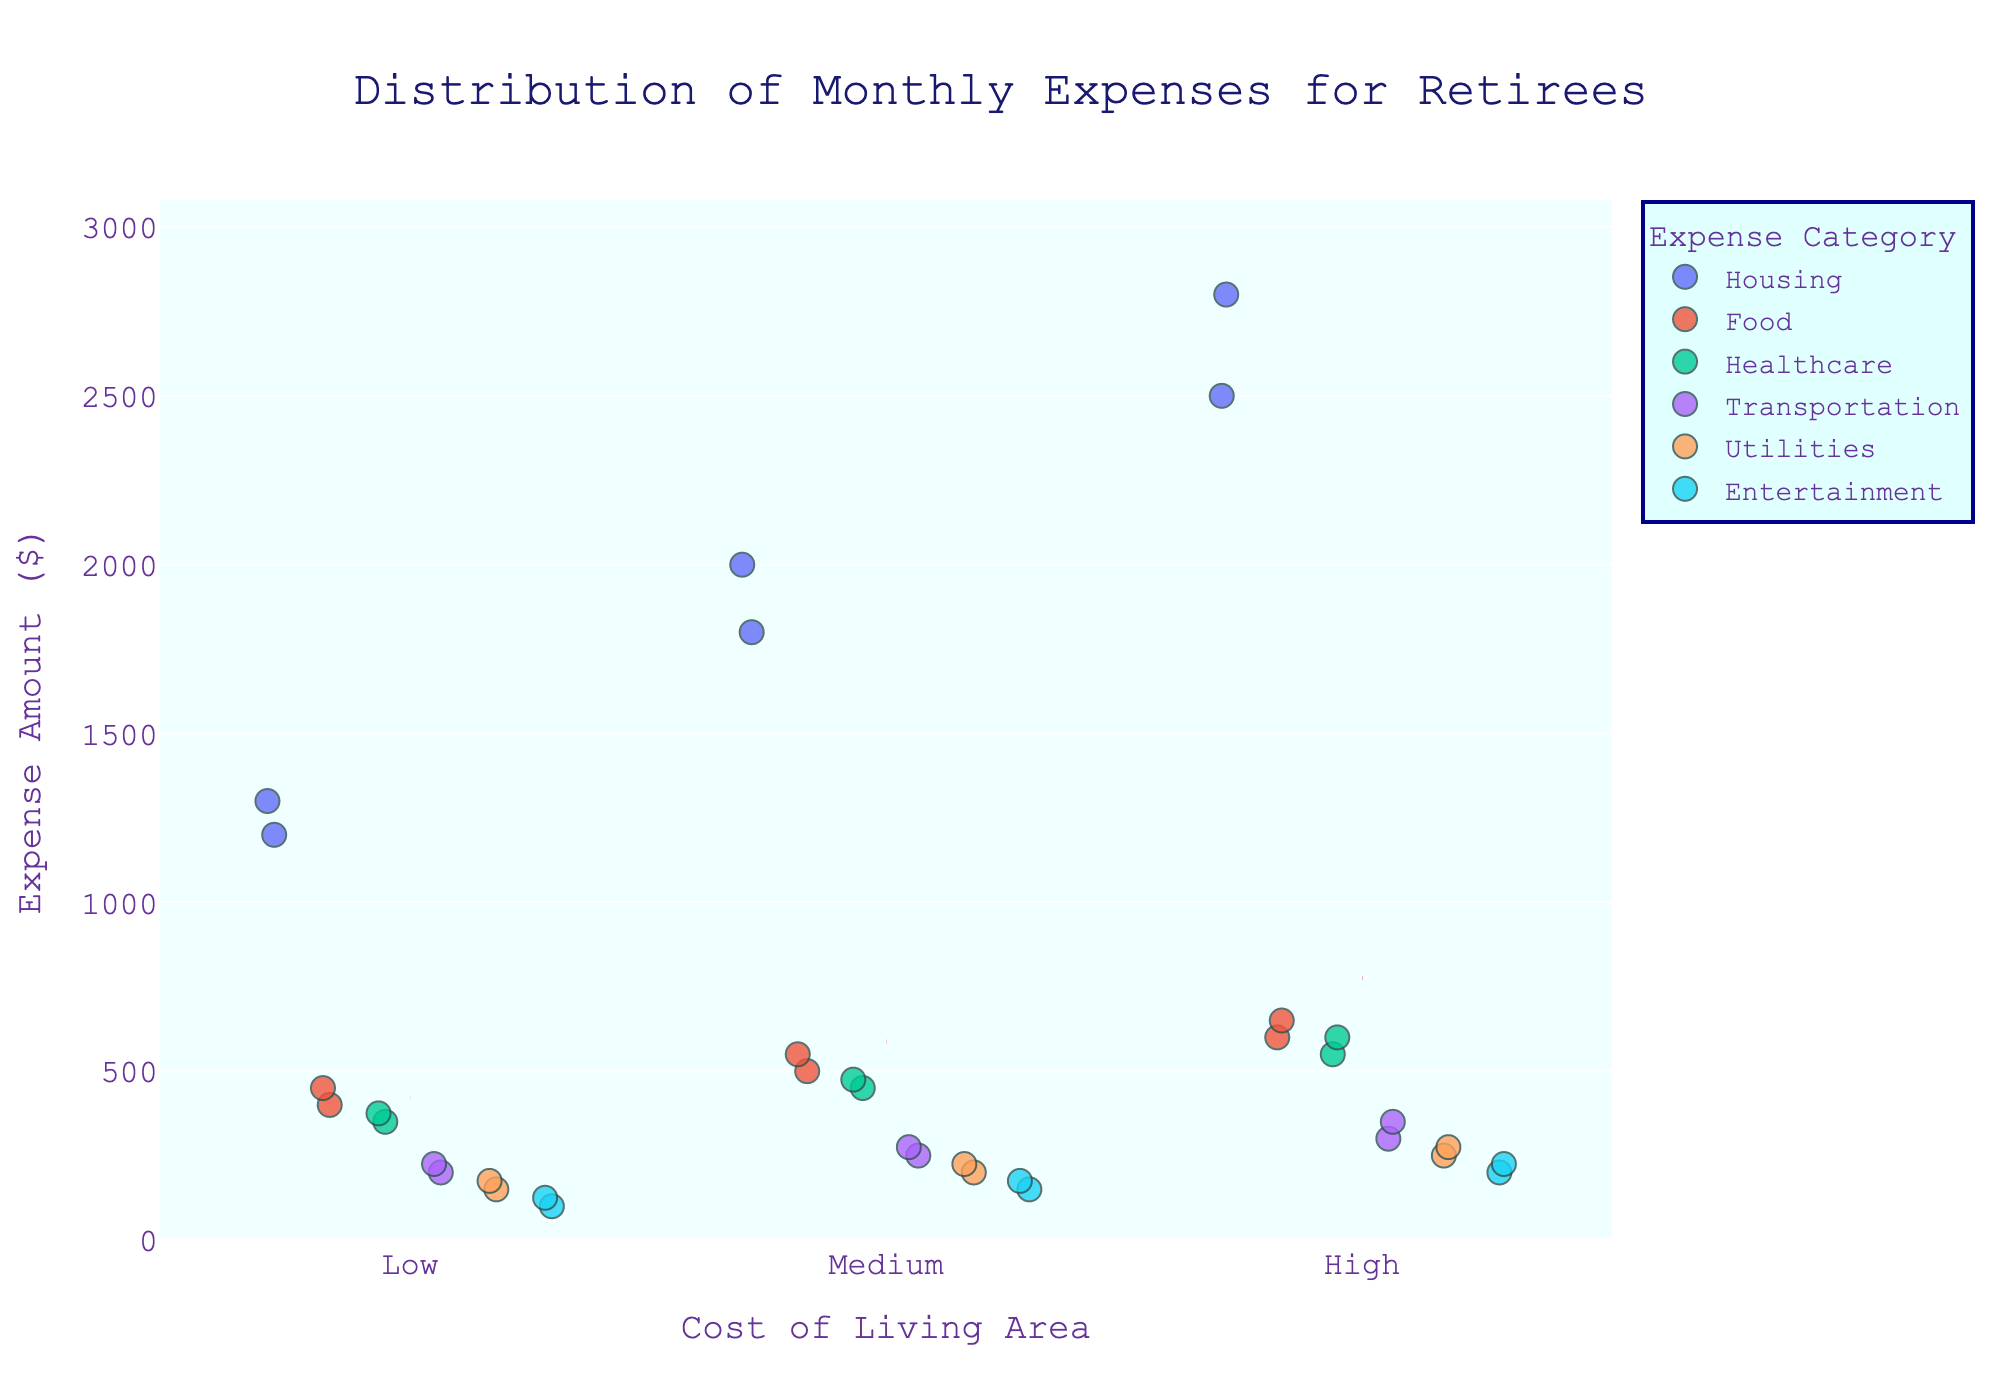What is the title of the figure? The title of the figure is displayed at the top center of the plot.
Answer: Distribution of Monthly Expenses for Retirees What are the categories of expenses shown in the plot? The color legend on the right side of the plot features the categories of expenses.
Answer: Housing, Food, Healthcare, Transportation, Utilities, Entertainment Which cost-of-living area has the highest average expense amount? Identify each cost-of-living area and compare where the mean red dashed line is highest. The "High" cost-of-living area has the highest average expense amount.
Answer: High Between which expense categories does the "Low" cost-of-living area show the largest difference in their amounts? For the "Low" cost-of-living area, compare the highest and lowest average expense categories visually. This difference is most apparent between Housing and Entertainment.
Answer: Housing and Entertainment How does the variability in healthcare expenses compare across different cost-of-living areas? Examine the spread of data points for healthcare expenses across the Low, Medium, and High living cost areas and note the range.
Answer: Variability increases with cost of living Which cost-of-living area has the least average expense amount for Transportation? Look for the red dashed mean lines within the transportation expense category across all areas.
Answer: Low What is the mean monthly expense amount for retirees in the "Medium" cost-of-living area? Identify the red dashed line representing the mean expense amount in the "Medium" cost-of-living area.
Answer: Sum of the amounts marked by the red dashed line in Medium area and then average them, approximately $912.50 How do food expenses in the "Low" and "High" cost-of-living areas compare? Compare the spread of dots in the food category for "Low" and "High" areas and measure the means.
Answer: Food expenses are lower in the Low cost-of-living area than in the High cost-of-living area Is there more variability in Utilities expenses or Entertainment expenses within each cost-of-living area? Compare the spread of data points for Utilities and Entertainment categories across all areas.
Answer: Entertainment has more variability across areas 